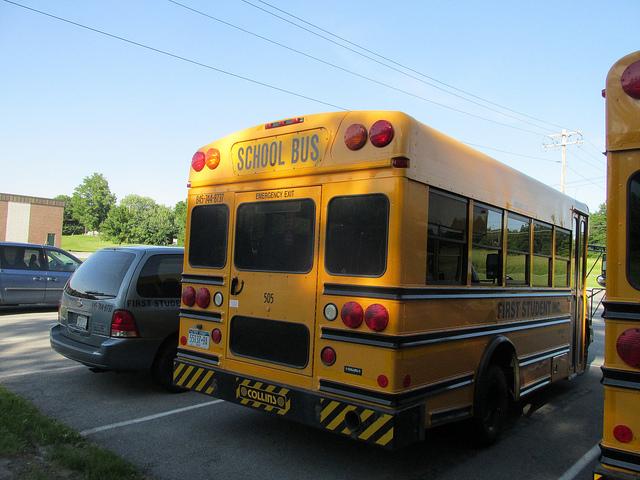Where is this bus probably headed?
Quick response, please. School. Do the two main vehicles in the picture have rear access?
Short answer required. Yes. Is the bus parked?
Quick response, please. Yes. How many passengers can each vehicle hold?
Give a very brief answer. 12. 